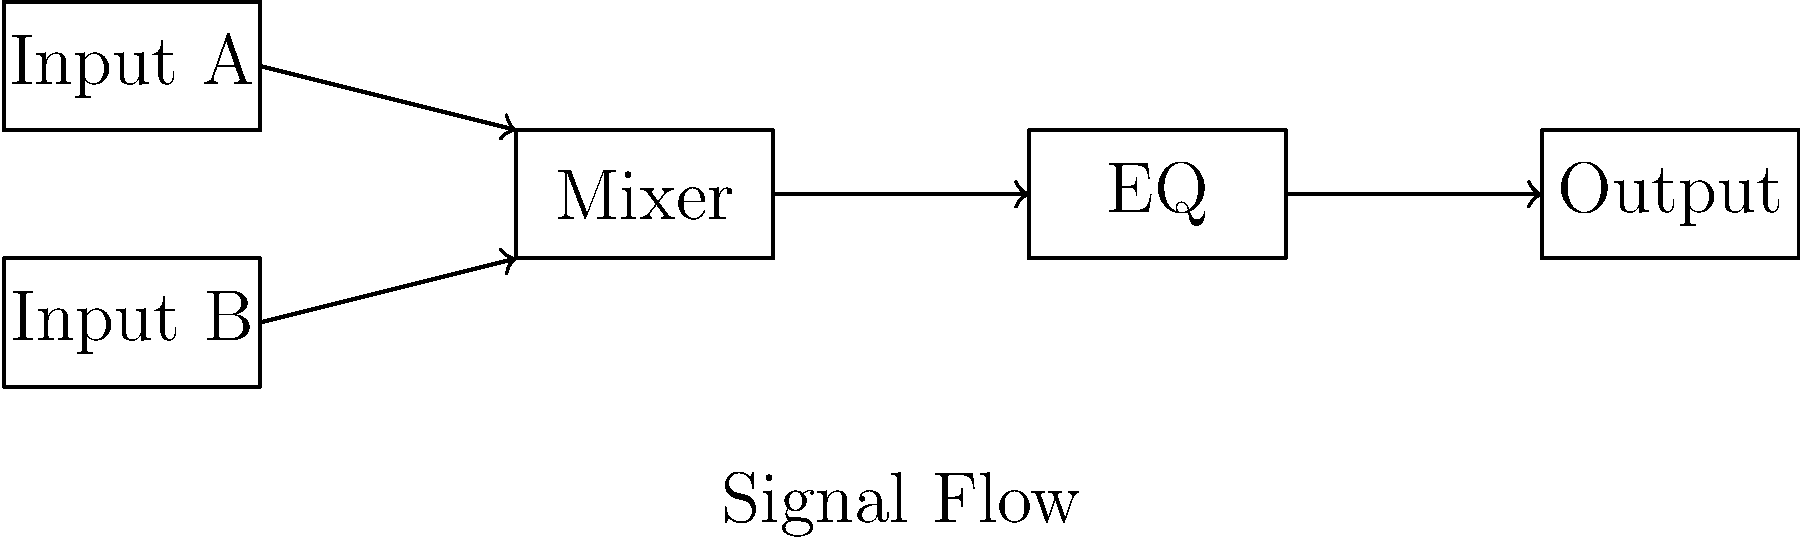As a DJ with an extensive collection of music from various pop culture franchises, you're setting up a basic mixer. Refer to the block diagram above, which represents a simple DJ mixer setup. What is the correct order of signal flow through the system? To understand the signal flow in this basic DJ mixer setup, let's follow the path step-by-step:

1. We start with two inputs, labeled "Input A" and "Input B". These could represent two different audio sources, such as two turntables or digital music players.

2. The arrows from both inputs lead to a single box labeled "Mixer". This indicates that the signals from both inputs are combined or blended in the mixer section.

3. From the mixer, a single arrow leads to the "EQ" box. EQ stands for equalizer, which allows the DJ to adjust the frequency balance of the mixed signal.

4. Finally, an arrow leads from the EQ section to the "Output" box, which represents the final audio output of the system.

Therefore, the signal flow follows this order:
Inputs (A and B) → Mixer → EQ → Output

This setup allows a DJ to blend two audio sources, adjust their relative levels in the mixer, shape the overall sound with the EQ, and then send the resulting signal to the output for amplification or further processing.
Answer: Inputs → Mixer → EQ → Output 